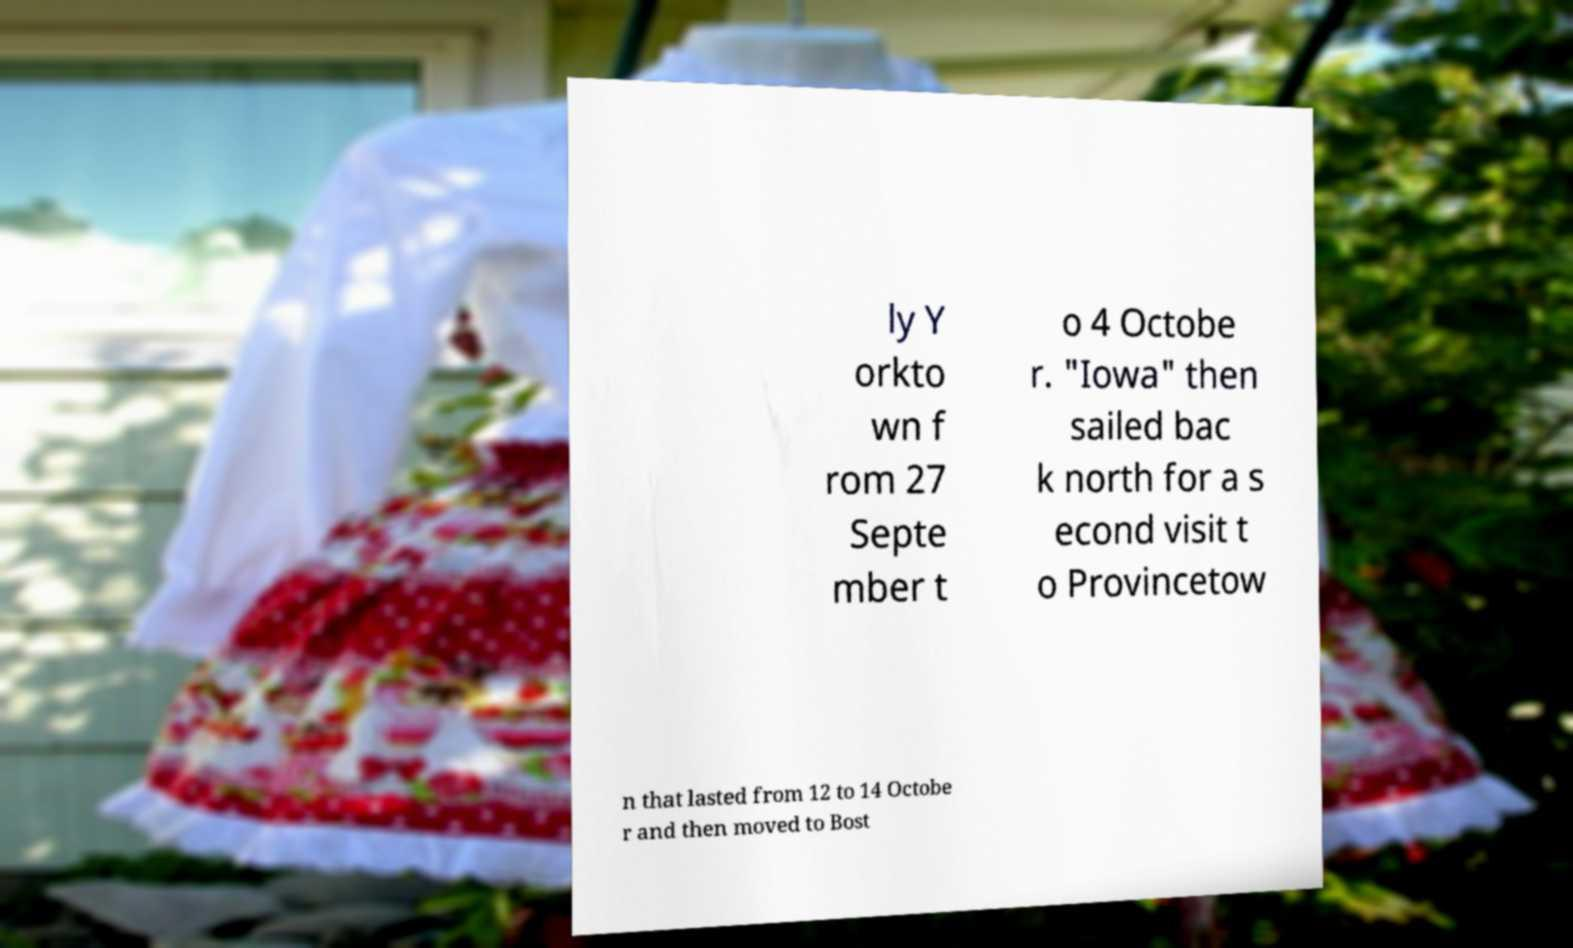There's text embedded in this image that I need extracted. Can you transcribe it verbatim? ly Y orkto wn f rom 27 Septe mber t o 4 Octobe r. "Iowa" then sailed bac k north for a s econd visit t o Provincetow n that lasted from 12 to 14 Octobe r and then moved to Bost 